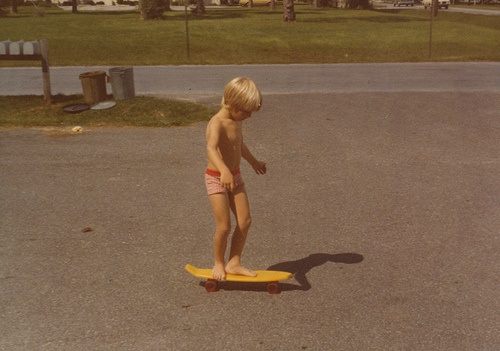Describe the objects in this image and their specific colors. I can see people in maroon, brown, and gray tones, skateboard in maroon, orange, gray, and olive tones, car in maroon, gray, and tan tones, and car in maroon and gray tones in this image. 